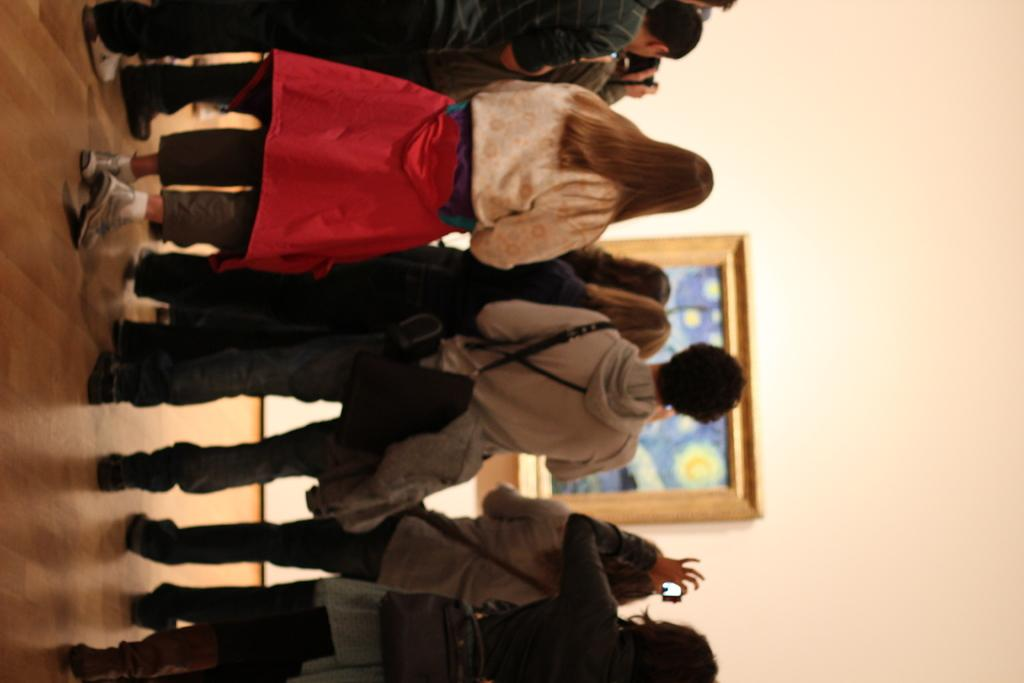What is happening in the image? There are people standing in the image. Where are the people standing? The people are standing on the floor. What can be seen on the wall in the image? There is a photo frame on the wall in the image. How much money is the boy holding in the image? There is no boy or money present in the image; it only features people standing on the floor and a photo frame on the wall. 